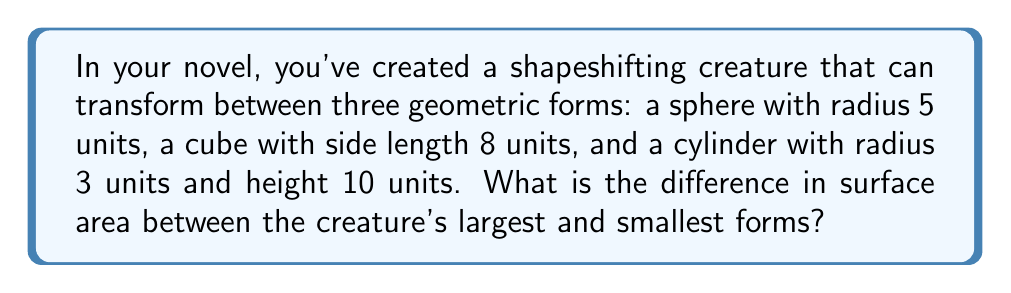Teach me how to tackle this problem. Let's calculate the surface area of each form:

1. Sphere:
   Surface area of a sphere: $A_s = 4\pi r^2$
   $A_s = 4\pi (5^2) = 100\pi$ square units

2. Cube:
   Surface area of a cube: $A_c = 6s^2$, where $s$ is the side length
   $A_c = 6(8^2) = 6(64) = 384$ square units

3. Cylinder:
   Surface area of a cylinder: $A_{cyl} = 2\pi r^2 + 2\pi rh$
   $A_{cyl} = 2\pi (3^2) + 2\pi (3)(10)$
   $A_{cyl} = 18\pi + 60\pi = 78\pi$ square units

Now, let's compare the surface areas:
Sphere: $100\pi \approx 314.16$ square units
Cube: $384$ square units
Cylinder: $78\pi \approx 245.04$ square units

The largest form is the cube, and the smallest is the cylinder.

The difference in surface area is:
$384 - 78\pi \approx 384 - 245.04 = 138.96$ square units
Answer: $384 - 78\pi$ square units (or approximately 138.96 square units) 